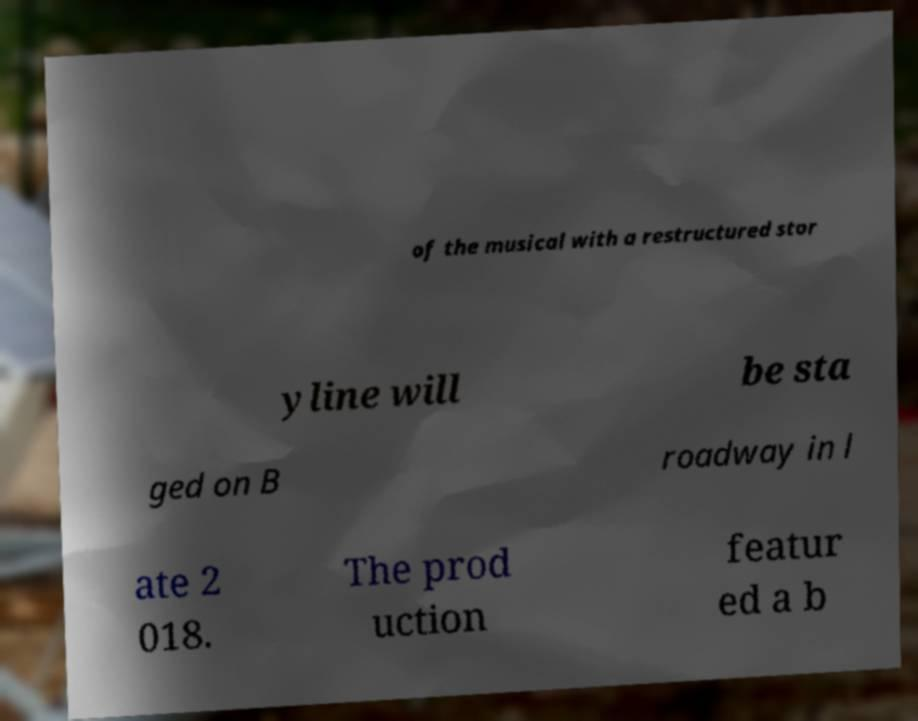There's text embedded in this image that I need extracted. Can you transcribe it verbatim? of the musical with a restructured stor yline will be sta ged on B roadway in l ate 2 018. The prod uction featur ed a b 